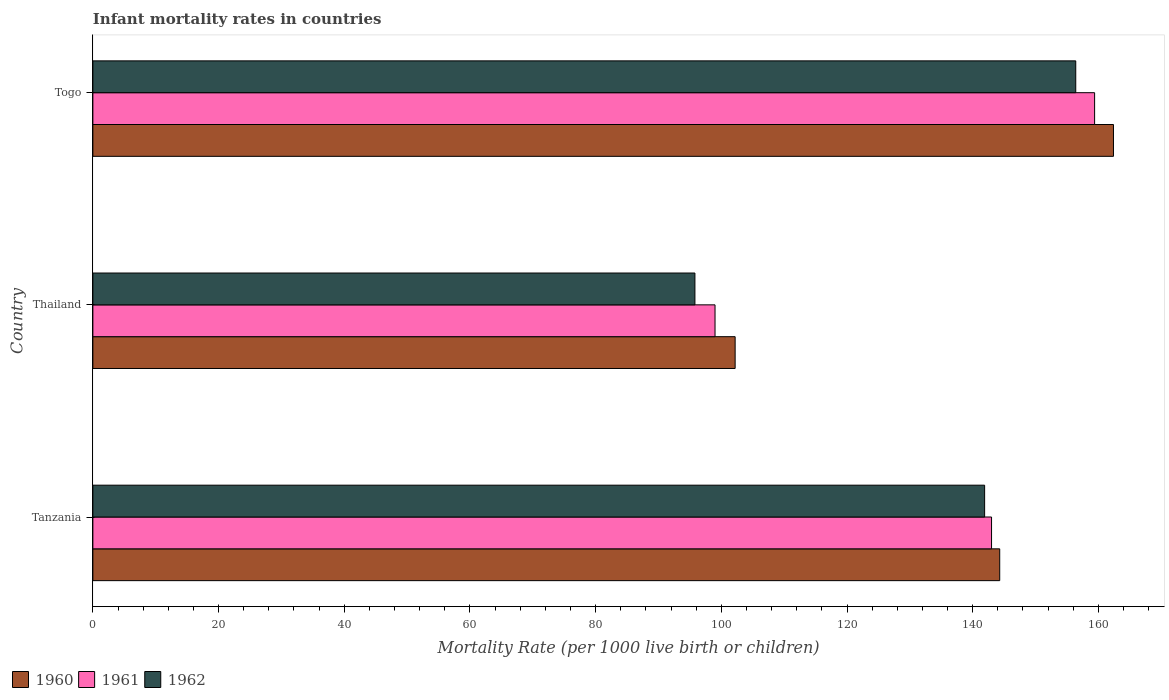Are the number of bars per tick equal to the number of legend labels?
Make the answer very short. Yes. What is the label of the 1st group of bars from the top?
Provide a short and direct response. Togo. What is the infant mortality rate in 1961 in Tanzania?
Provide a succinct answer. 143. Across all countries, what is the maximum infant mortality rate in 1962?
Your response must be concise. 156.4. Across all countries, what is the minimum infant mortality rate in 1960?
Give a very brief answer. 102.2. In which country was the infant mortality rate in 1962 maximum?
Ensure brevity in your answer.  Togo. In which country was the infant mortality rate in 1961 minimum?
Make the answer very short. Thailand. What is the total infant mortality rate in 1962 in the graph?
Provide a succinct answer. 394.1. What is the difference between the infant mortality rate in 1960 in Thailand and that in Togo?
Give a very brief answer. -60.2. What is the difference between the infant mortality rate in 1962 in Thailand and the infant mortality rate in 1961 in Togo?
Ensure brevity in your answer.  -63.6. What is the average infant mortality rate in 1961 per country?
Keep it short and to the point. 133.8. What is the difference between the infant mortality rate in 1960 and infant mortality rate in 1962 in Thailand?
Keep it short and to the point. 6.4. In how many countries, is the infant mortality rate in 1960 greater than 84 ?
Keep it short and to the point. 3. What is the ratio of the infant mortality rate in 1960 in Tanzania to that in Thailand?
Offer a terse response. 1.41. Is the difference between the infant mortality rate in 1960 in Tanzania and Togo greater than the difference between the infant mortality rate in 1962 in Tanzania and Togo?
Give a very brief answer. No. What is the difference between the highest and the lowest infant mortality rate in 1960?
Make the answer very short. 60.2. Is the sum of the infant mortality rate in 1962 in Tanzania and Thailand greater than the maximum infant mortality rate in 1960 across all countries?
Ensure brevity in your answer.  Yes. What does the 3rd bar from the top in Togo represents?
Your response must be concise. 1960. Is it the case that in every country, the sum of the infant mortality rate in 1960 and infant mortality rate in 1962 is greater than the infant mortality rate in 1961?
Give a very brief answer. Yes. How many countries are there in the graph?
Provide a succinct answer. 3. What is the difference between two consecutive major ticks on the X-axis?
Your response must be concise. 20. Are the values on the major ticks of X-axis written in scientific E-notation?
Offer a very short reply. No. Does the graph contain any zero values?
Offer a terse response. No. Does the graph contain grids?
Keep it short and to the point. No. How many legend labels are there?
Provide a succinct answer. 3. What is the title of the graph?
Give a very brief answer. Infant mortality rates in countries. What is the label or title of the X-axis?
Offer a terse response. Mortality Rate (per 1000 live birth or children). What is the label or title of the Y-axis?
Your answer should be compact. Country. What is the Mortality Rate (per 1000 live birth or children) of 1960 in Tanzania?
Your answer should be very brief. 144.3. What is the Mortality Rate (per 1000 live birth or children) in 1961 in Tanzania?
Offer a terse response. 143. What is the Mortality Rate (per 1000 live birth or children) in 1962 in Tanzania?
Provide a succinct answer. 141.9. What is the Mortality Rate (per 1000 live birth or children) in 1960 in Thailand?
Keep it short and to the point. 102.2. What is the Mortality Rate (per 1000 live birth or children) of 1961 in Thailand?
Your answer should be compact. 99. What is the Mortality Rate (per 1000 live birth or children) in 1962 in Thailand?
Offer a very short reply. 95.8. What is the Mortality Rate (per 1000 live birth or children) of 1960 in Togo?
Ensure brevity in your answer.  162.4. What is the Mortality Rate (per 1000 live birth or children) of 1961 in Togo?
Give a very brief answer. 159.4. What is the Mortality Rate (per 1000 live birth or children) of 1962 in Togo?
Your answer should be compact. 156.4. Across all countries, what is the maximum Mortality Rate (per 1000 live birth or children) in 1960?
Keep it short and to the point. 162.4. Across all countries, what is the maximum Mortality Rate (per 1000 live birth or children) of 1961?
Provide a short and direct response. 159.4. Across all countries, what is the maximum Mortality Rate (per 1000 live birth or children) in 1962?
Your answer should be very brief. 156.4. Across all countries, what is the minimum Mortality Rate (per 1000 live birth or children) in 1960?
Your answer should be very brief. 102.2. Across all countries, what is the minimum Mortality Rate (per 1000 live birth or children) in 1962?
Your answer should be compact. 95.8. What is the total Mortality Rate (per 1000 live birth or children) in 1960 in the graph?
Offer a very short reply. 408.9. What is the total Mortality Rate (per 1000 live birth or children) of 1961 in the graph?
Your answer should be very brief. 401.4. What is the total Mortality Rate (per 1000 live birth or children) of 1962 in the graph?
Keep it short and to the point. 394.1. What is the difference between the Mortality Rate (per 1000 live birth or children) in 1960 in Tanzania and that in Thailand?
Provide a short and direct response. 42.1. What is the difference between the Mortality Rate (per 1000 live birth or children) of 1962 in Tanzania and that in Thailand?
Keep it short and to the point. 46.1. What is the difference between the Mortality Rate (per 1000 live birth or children) in 1960 in Tanzania and that in Togo?
Your response must be concise. -18.1. What is the difference between the Mortality Rate (per 1000 live birth or children) of 1961 in Tanzania and that in Togo?
Your response must be concise. -16.4. What is the difference between the Mortality Rate (per 1000 live birth or children) in 1960 in Thailand and that in Togo?
Make the answer very short. -60.2. What is the difference between the Mortality Rate (per 1000 live birth or children) of 1961 in Thailand and that in Togo?
Ensure brevity in your answer.  -60.4. What is the difference between the Mortality Rate (per 1000 live birth or children) in 1962 in Thailand and that in Togo?
Keep it short and to the point. -60.6. What is the difference between the Mortality Rate (per 1000 live birth or children) in 1960 in Tanzania and the Mortality Rate (per 1000 live birth or children) in 1961 in Thailand?
Your response must be concise. 45.3. What is the difference between the Mortality Rate (per 1000 live birth or children) in 1960 in Tanzania and the Mortality Rate (per 1000 live birth or children) in 1962 in Thailand?
Offer a very short reply. 48.5. What is the difference between the Mortality Rate (per 1000 live birth or children) in 1961 in Tanzania and the Mortality Rate (per 1000 live birth or children) in 1962 in Thailand?
Provide a succinct answer. 47.2. What is the difference between the Mortality Rate (per 1000 live birth or children) of 1960 in Tanzania and the Mortality Rate (per 1000 live birth or children) of 1961 in Togo?
Your answer should be very brief. -15.1. What is the difference between the Mortality Rate (per 1000 live birth or children) of 1960 in Tanzania and the Mortality Rate (per 1000 live birth or children) of 1962 in Togo?
Ensure brevity in your answer.  -12.1. What is the difference between the Mortality Rate (per 1000 live birth or children) of 1960 in Thailand and the Mortality Rate (per 1000 live birth or children) of 1961 in Togo?
Make the answer very short. -57.2. What is the difference between the Mortality Rate (per 1000 live birth or children) in 1960 in Thailand and the Mortality Rate (per 1000 live birth or children) in 1962 in Togo?
Provide a short and direct response. -54.2. What is the difference between the Mortality Rate (per 1000 live birth or children) in 1961 in Thailand and the Mortality Rate (per 1000 live birth or children) in 1962 in Togo?
Make the answer very short. -57.4. What is the average Mortality Rate (per 1000 live birth or children) of 1960 per country?
Offer a terse response. 136.3. What is the average Mortality Rate (per 1000 live birth or children) of 1961 per country?
Provide a short and direct response. 133.8. What is the average Mortality Rate (per 1000 live birth or children) in 1962 per country?
Give a very brief answer. 131.37. What is the difference between the Mortality Rate (per 1000 live birth or children) of 1960 and Mortality Rate (per 1000 live birth or children) of 1962 in Tanzania?
Ensure brevity in your answer.  2.4. What is the difference between the Mortality Rate (per 1000 live birth or children) of 1960 and Mortality Rate (per 1000 live birth or children) of 1962 in Thailand?
Make the answer very short. 6.4. What is the ratio of the Mortality Rate (per 1000 live birth or children) of 1960 in Tanzania to that in Thailand?
Provide a succinct answer. 1.41. What is the ratio of the Mortality Rate (per 1000 live birth or children) of 1961 in Tanzania to that in Thailand?
Your answer should be very brief. 1.44. What is the ratio of the Mortality Rate (per 1000 live birth or children) of 1962 in Tanzania to that in Thailand?
Your answer should be compact. 1.48. What is the ratio of the Mortality Rate (per 1000 live birth or children) in 1960 in Tanzania to that in Togo?
Provide a succinct answer. 0.89. What is the ratio of the Mortality Rate (per 1000 live birth or children) in 1961 in Tanzania to that in Togo?
Ensure brevity in your answer.  0.9. What is the ratio of the Mortality Rate (per 1000 live birth or children) of 1962 in Tanzania to that in Togo?
Your answer should be compact. 0.91. What is the ratio of the Mortality Rate (per 1000 live birth or children) in 1960 in Thailand to that in Togo?
Provide a short and direct response. 0.63. What is the ratio of the Mortality Rate (per 1000 live birth or children) of 1961 in Thailand to that in Togo?
Offer a very short reply. 0.62. What is the ratio of the Mortality Rate (per 1000 live birth or children) of 1962 in Thailand to that in Togo?
Provide a short and direct response. 0.61. What is the difference between the highest and the second highest Mortality Rate (per 1000 live birth or children) in 1960?
Ensure brevity in your answer.  18.1. What is the difference between the highest and the second highest Mortality Rate (per 1000 live birth or children) of 1961?
Give a very brief answer. 16.4. What is the difference between the highest and the lowest Mortality Rate (per 1000 live birth or children) of 1960?
Give a very brief answer. 60.2. What is the difference between the highest and the lowest Mortality Rate (per 1000 live birth or children) in 1961?
Ensure brevity in your answer.  60.4. What is the difference between the highest and the lowest Mortality Rate (per 1000 live birth or children) of 1962?
Offer a very short reply. 60.6. 